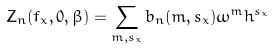<formula> <loc_0><loc_0><loc_500><loc_500>Z _ { n } ( f _ { x } , 0 , \beta ) = \sum _ { m , s _ { x } } b _ { n } ( m , s _ { x } ) \omega ^ { m } h ^ { s _ { x } }</formula> 